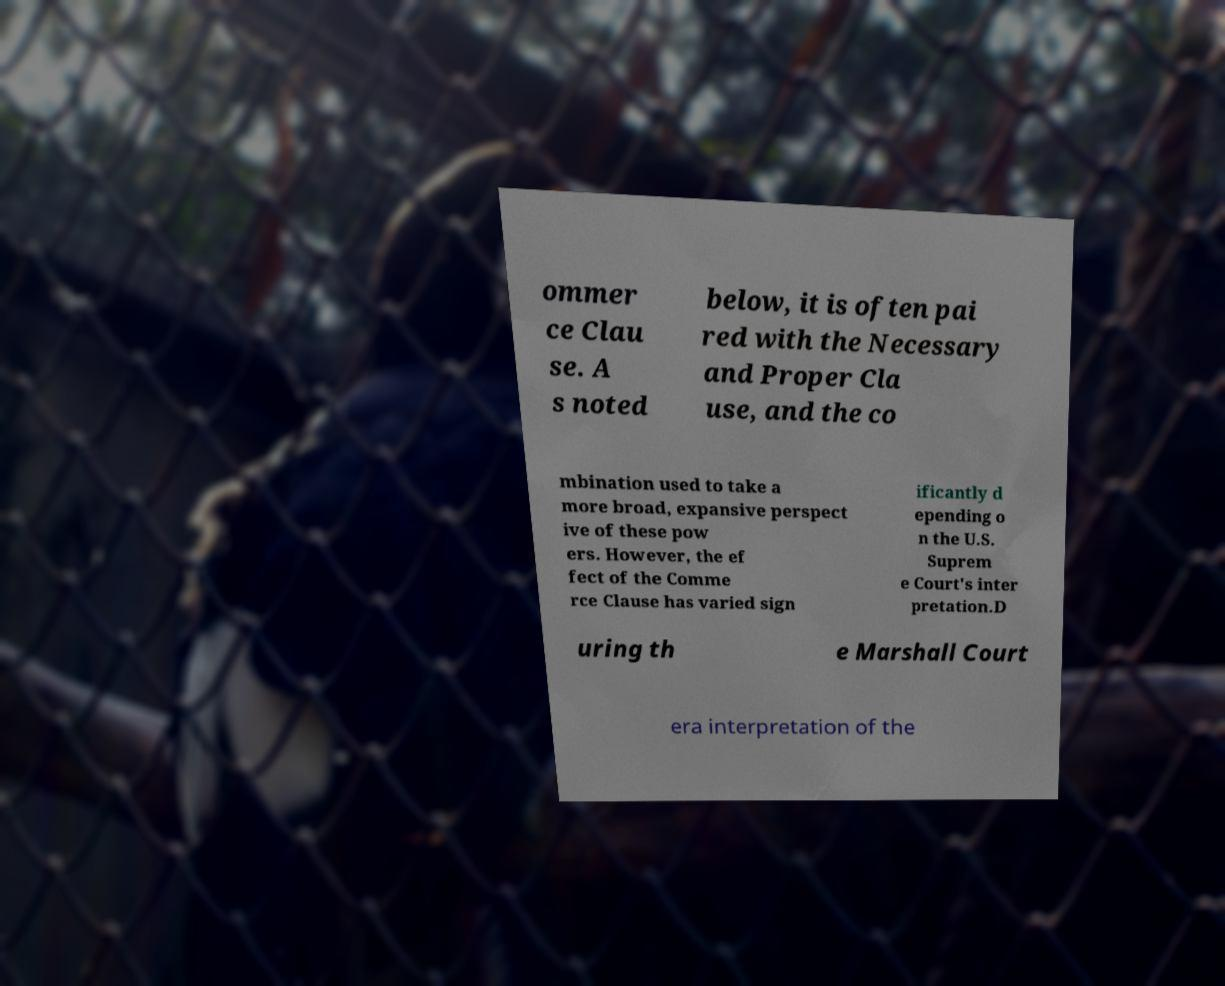I need the written content from this picture converted into text. Can you do that? ommer ce Clau se. A s noted below, it is often pai red with the Necessary and Proper Cla use, and the co mbination used to take a more broad, expansive perspect ive of these pow ers. However, the ef fect of the Comme rce Clause has varied sign ificantly d epending o n the U.S. Suprem e Court's inter pretation.D uring th e Marshall Court era interpretation of the 